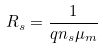Convert formula to latex. <formula><loc_0><loc_0><loc_500><loc_500>R _ { s } = \frac { 1 } { q n _ { s } \mu _ { m } }</formula> 